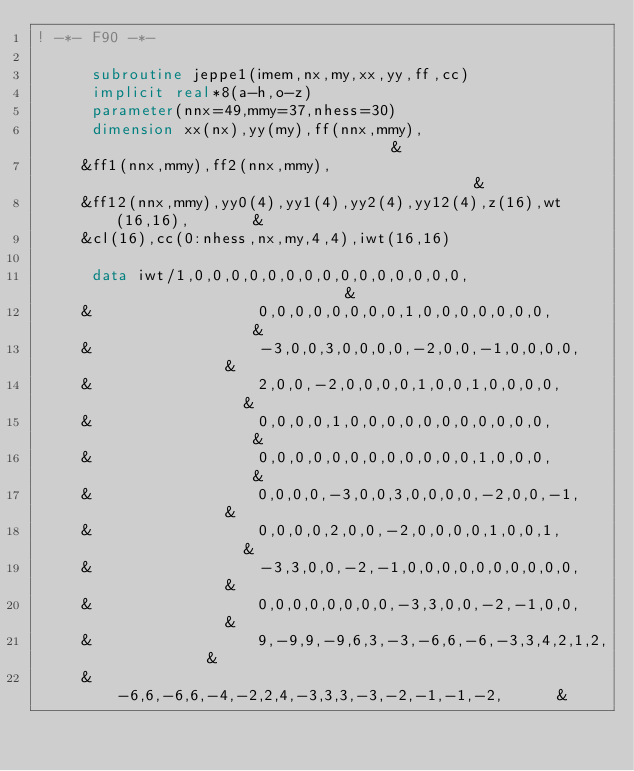Convert code to text. <code><loc_0><loc_0><loc_500><loc_500><_FORTRAN_>! -*- F90 -*-
                                                                        
      subroutine jeppe1(imem,nx,my,xx,yy,ff,cc) 
      implicit real*8(a-h,o-z) 
      parameter(nnx=49,mmy=37,nhess=30) 
      dimension xx(nx),yy(my),ff(nnx,mmy),                              &
     &ff1(nnx,mmy),ff2(nnx,mmy),                                        &
     &ff12(nnx,mmy),yy0(4),yy1(4),yy2(4),yy12(4),z(16),wt(16,16),       &
     &cl(16),cc(0:nhess,nx,my,4,4),iwt(16,16)                           
                                                                        
      data iwt/1,0,0,0,0,0,0,0,0,0,0,0,0,0,0,0,                         &
     &                  0,0,0,0,0,0,0,0,1,0,0,0,0,0,0,0,                &
     &                  -3,0,0,3,0,0,0,0,-2,0,0,-1,0,0,0,0,             &
     &                  2,0,0,-2,0,0,0,0,1,0,0,1,0,0,0,0,               &
     &                  0,0,0,0,1,0,0,0,0,0,0,0,0,0,0,0,                &
     &                  0,0,0,0,0,0,0,0,0,0,0,0,1,0,0,0,                &
     &                  0,0,0,0,-3,0,0,3,0,0,0,0,-2,0,0,-1,             &
     &                  0,0,0,0,2,0,0,-2,0,0,0,0,1,0,0,1,               &
     &                  -3,3,0,0,-2,-1,0,0,0,0,0,0,0,0,0,0,             &
     &                  0,0,0,0,0,0,0,0,-3,3,0,0,-2,-1,0,0,             &
     &                  9,-9,9,-9,6,3,-3,-6,6,-6,-3,3,4,2,1,2,          &
     &                  -6,6,-6,6,-4,-2,2,4,-3,3,3,-3,-2,-1,-1,-2,      &</code> 